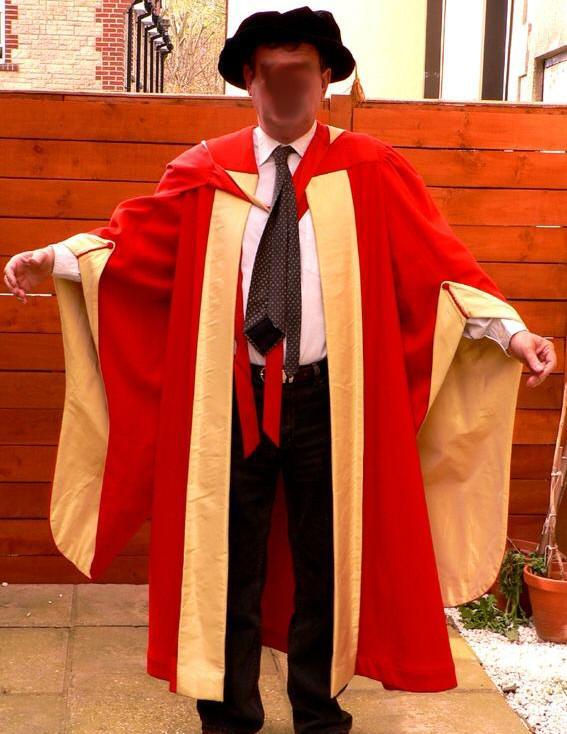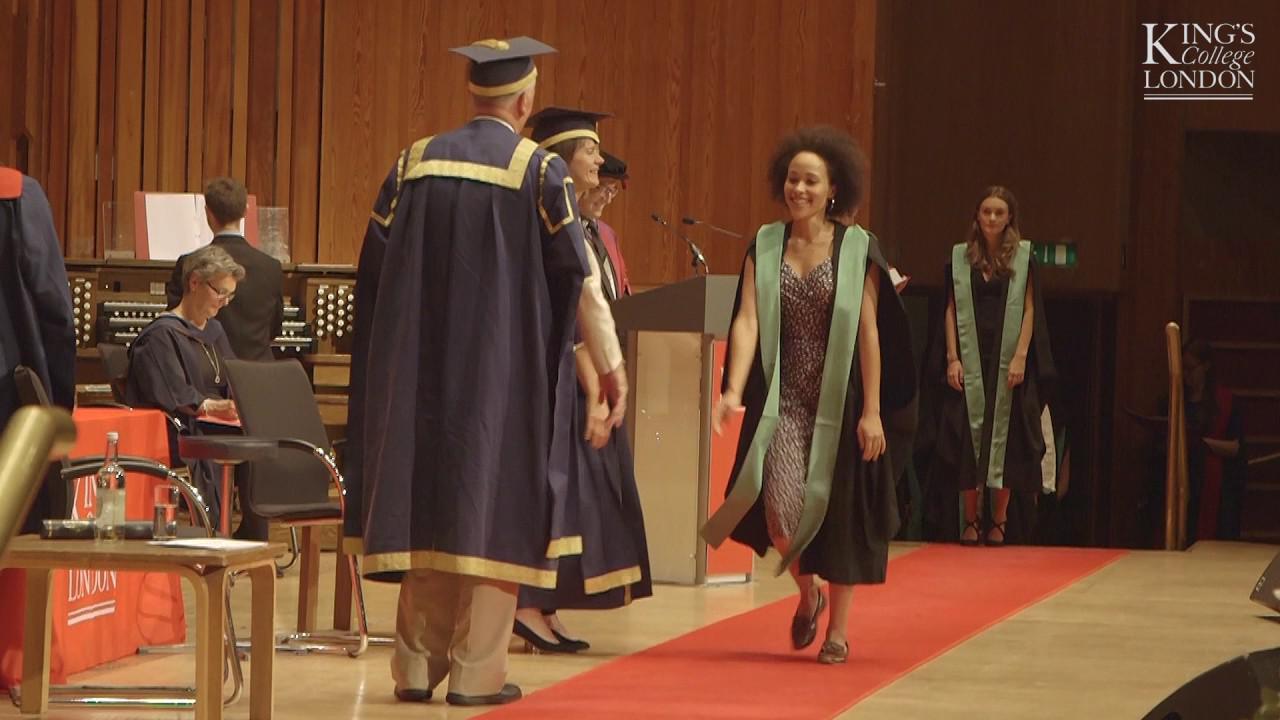The first image is the image on the left, the second image is the image on the right. Analyze the images presented: Is the assertion "The right image contains no more than two people wearing graduation gowns." valid? Answer yes or no. No. The first image is the image on the left, the second image is the image on the right. Evaluate the accuracy of this statement regarding the images: "An image shows a woman in a burgundy graduation robe next to a man in a bright red robe with pink and burgundy sashes.". Is it true? Answer yes or no. No. 